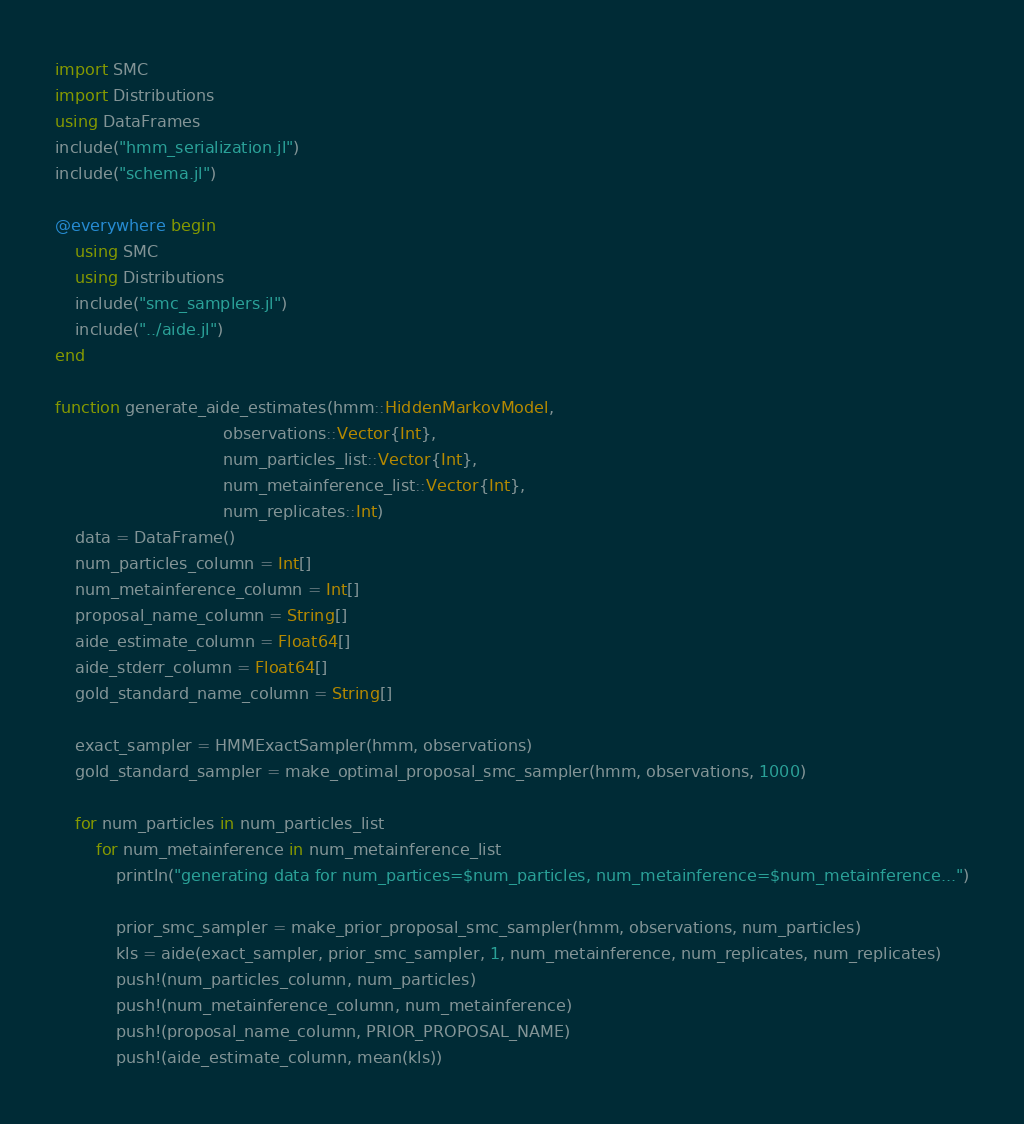<code> <loc_0><loc_0><loc_500><loc_500><_Julia_>import SMC
import Distributions
using DataFrames
include("hmm_serialization.jl")
include("schema.jl")

@everywhere begin
    using SMC
    using Distributions
    include("smc_samplers.jl")
    include("../aide.jl")
end

function generate_aide_estimates(hmm::HiddenMarkovModel,
                                 observations::Vector{Int},
                                 num_particles_list::Vector{Int},
                                 num_metainference_list::Vector{Int},
                                 num_replicates::Int)
    data = DataFrame()
    num_particles_column = Int[]
    num_metainference_column = Int[]
    proposal_name_column = String[]
    aide_estimate_column = Float64[]
    aide_stderr_column = Float64[]
    gold_standard_name_column = String[]

    exact_sampler = HMMExactSampler(hmm, observations)
    gold_standard_sampler = make_optimal_proposal_smc_sampler(hmm, observations, 1000)
    
    for num_particles in num_particles_list
        for num_metainference in num_metainference_list
            println("generating data for num_partices=$num_particles, num_metainference=$num_metainference...")
            
            prior_smc_sampler = make_prior_proposal_smc_sampler(hmm, observations, num_particles)
            kls = aide(exact_sampler, prior_smc_sampler, 1, num_metainference, num_replicates, num_replicates)
            push!(num_particles_column, num_particles)
            push!(num_metainference_column, num_metainference)
            push!(proposal_name_column, PRIOR_PROPOSAL_NAME)
            push!(aide_estimate_column, mean(kls))</code> 